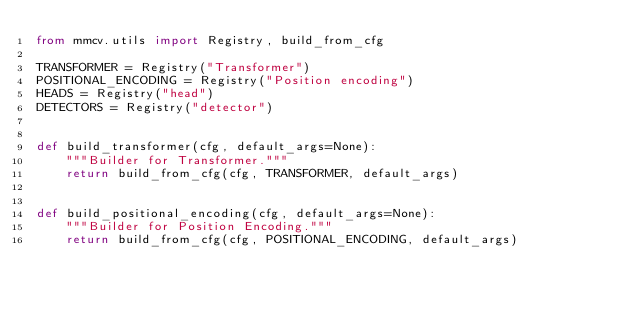Convert code to text. <code><loc_0><loc_0><loc_500><loc_500><_Python_>from mmcv.utils import Registry, build_from_cfg

TRANSFORMER = Registry("Transformer")
POSITIONAL_ENCODING = Registry("Position encoding")
HEADS = Registry("head")
DETECTORS = Registry("detector")


def build_transformer(cfg, default_args=None):
    """Builder for Transformer."""
    return build_from_cfg(cfg, TRANSFORMER, default_args)


def build_positional_encoding(cfg, default_args=None):
    """Builder for Position Encoding."""
    return build_from_cfg(cfg, POSITIONAL_ENCODING, default_args)
</code> 